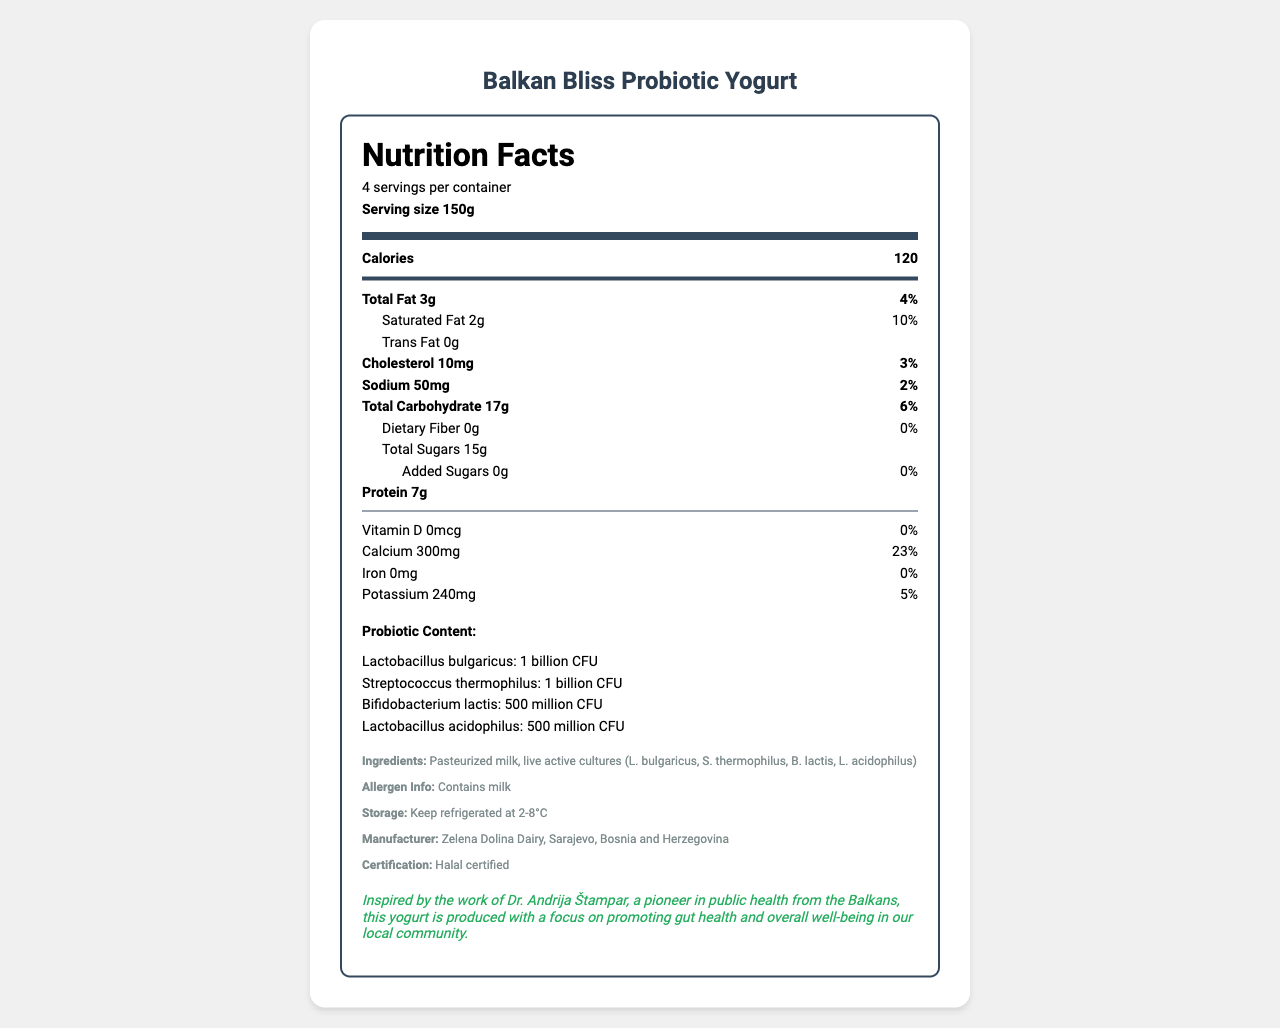who is the manufacturer of Balkan Bliss Probiotic Yogurt? The manufacturer information is listed under the additional info section of the document.
Answer: Zelena Dolina Dairy, Sarajevo, Bosnia and Herzegovina what is the serving size of Balkan Bliss Probiotic Yogurt? The serving size is mentioned in the header of the nutrition facts section.
Answer: 150g how many servings are there per container? The number of servings per container is mentioned in the serving info.
Answer: 4 what is the amount of calcium per serving? The amount of calcium per serving is found in the nutrition item list.
Answer: 300mg name one of the beneficial bacteria present in the probiotic yogurt. One of the beneficial bacteria mentioned under the probiotic content section is Lactobacillus bulgaricus.
Answer: Lactobacillus bulgaricus how many grams of total sugars are in a serving? The amount of total sugars is listed under the nutrition item for total carbohydrate.
Answer: 15g list all the live active cultures mentioned in the ingredients. The list of live active cultures is provided in the ingredients section.
Answer: L. bulgaricus, S. thermophilus, B. lactis, L. acidophilus what is the total fat percentage of daily value? The percentage of daily value for total fat is mentioned as 4% next to the total fat amount.
Answer: 4% which one of these bacteria has the highest CFU content? A. Lactobacillus bulgaricus B. Lactobacillus acidophilus C. Bifidobacterium lactis D. Streptococcus thermophilus The probiotic content shows that Lactobacillus bulgaricus has 1 billion CFU, which is the highest among the listed bacteria.
Answer: A. Lactobacillus bulgaricus what is the purpose of the public health note mentioned in the document? A. To showcase the yogurts' flavors B. To highlight the manufacturing process C. To promote gut health and well-being D. To list the allergens The public health note mentions that the yogurt is produced with a focus on promoting gut health and overall well-being.
Answer: C. To promote gut health and well-being is the yogurt certified Halal? The certification section states that the yogurt is Halal certified.
Answer: Yes could you list the ingredients of the yogurt? The ingredients are listed under the additional info section.
Answer: Pasteurized milk, live active cultures (L. bulgaricus, S. thermophilus, B. lactis, L. acidophilus) how would you summarize the main idea of this document? The document offers a detailed look into the nutritional benefits and specific probiotic content of the locally-produced Yogurt, as well as important storage and allergen information, making it clear that this product is designed with public health in mind.
Answer: The document provides comprehensive nutrition information about Balkan Bliss Probiotic Yogurt, including serving size, calories, fat content, sugar content, probiotic content, and additional details like ingredients, allergen information, storage instructions, and a public health note emphasizing the benefits of the yogurt for gut health and overall well-being. The yogurt is manufactured by Zelena Dolina Dairy and is Halal certified. what is the exact vitamin D content in the yogurt? The vitamin D content listed under the nutrition section is 0mcg.
Answer: 0mcg what is the purpose of the thick divider in the nutrition label? The thick divider visually separates the information on calories from the detailed breakdown of other nutrients.
Answer: To separate the calorie information from the rest of the nutritional data how much protein does each serving provide? The amount of protein per serving is listed in the nutrition facts.
Answer: 7g 